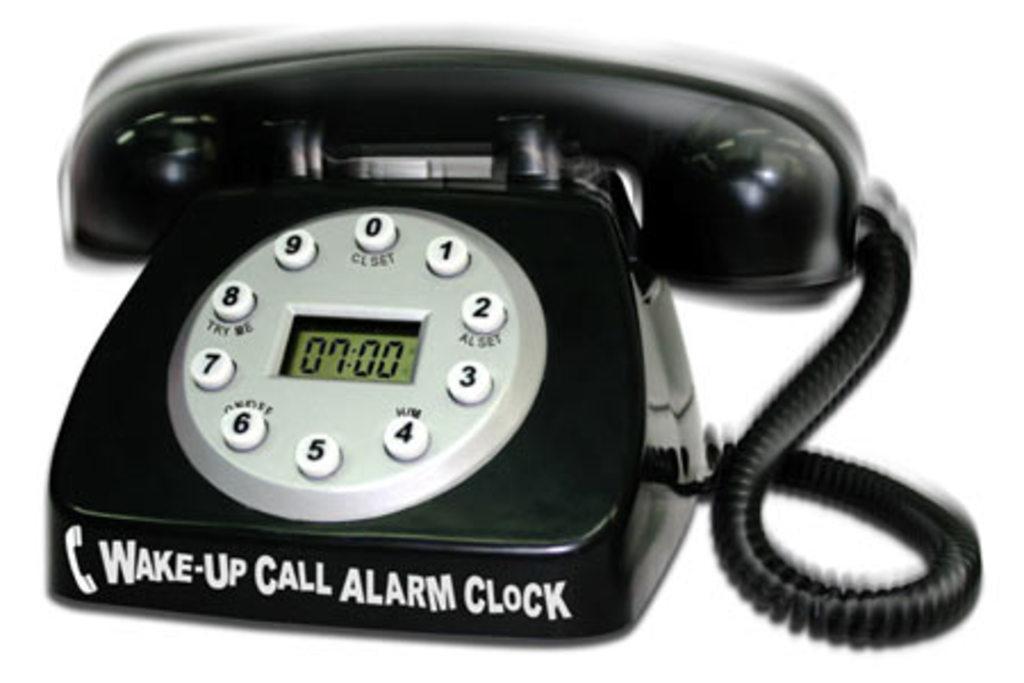What time is shown on the center lcd clock?
Make the answer very short. 7:00. What is written on the bottom of the phone/clock?
Provide a short and direct response. Wake-up call alarm clock. 